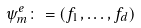<formula> <loc_0><loc_0><loc_500><loc_500>\psi ^ { e } _ { m } \colon = ( f _ { 1 } , \dots , f _ { d } )</formula> 